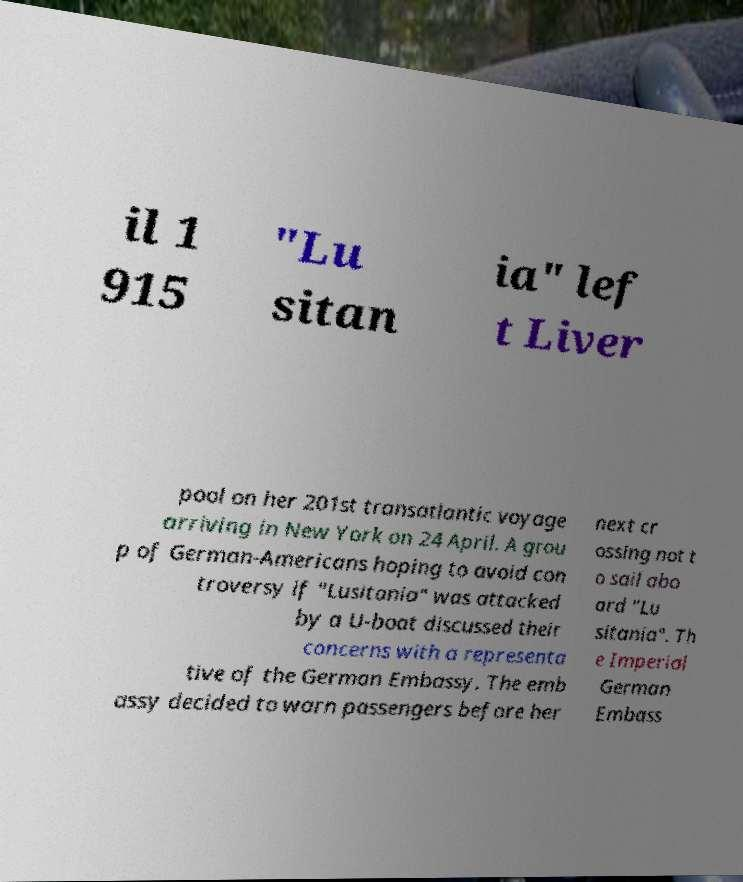Can you read and provide the text displayed in the image?This photo seems to have some interesting text. Can you extract and type it out for me? il 1 915 "Lu sitan ia" lef t Liver pool on her 201st transatlantic voyage arriving in New York on 24 April. A grou p of German-Americans hoping to avoid con troversy if "Lusitania" was attacked by a U-boat discussed their concerns with a representa tive of the German Embassy. The emb assy decided to warn passengers before her next cr ossing not t o sail abo ard "Lu sitania". Th e Imperial German Embass 